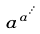<formula> <loc_0><loc_0><loc_500><loc_500>a ^ { a ^ { \cdot ^ { \cdot ^ { \cdot } } } }</formula> 